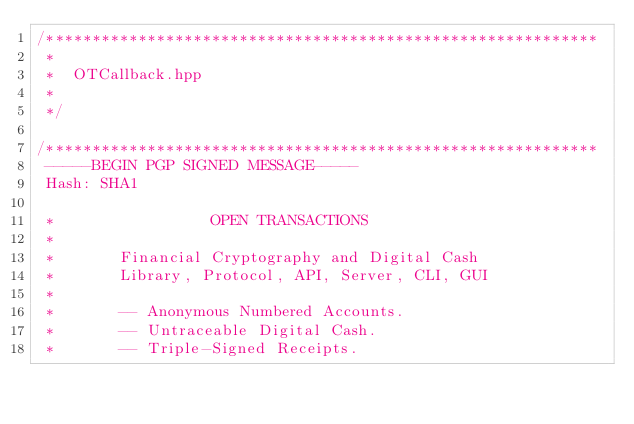Convert code to text. <code><loc_0><loc_0><loc_500><loc_500><_C++_>/************************************************************
 *
 *  OTCallback.hpp
 *
 */

/************************************************************
 -----BEGIN PGP SIGNED MESSAGE-----
 Hash: SHA1

 *                 OPEN TRANSACTIONS
 *
 *       Financial Cryptography and Digital Cash
 *       Library, Protocol, API, Server, CLI, GUI
 *
 *       -- Anonymous Numbered Accounts.
 *       -- Untraceable Digital Cash.
 *       -- Triple-Signed Receipts.</code> 